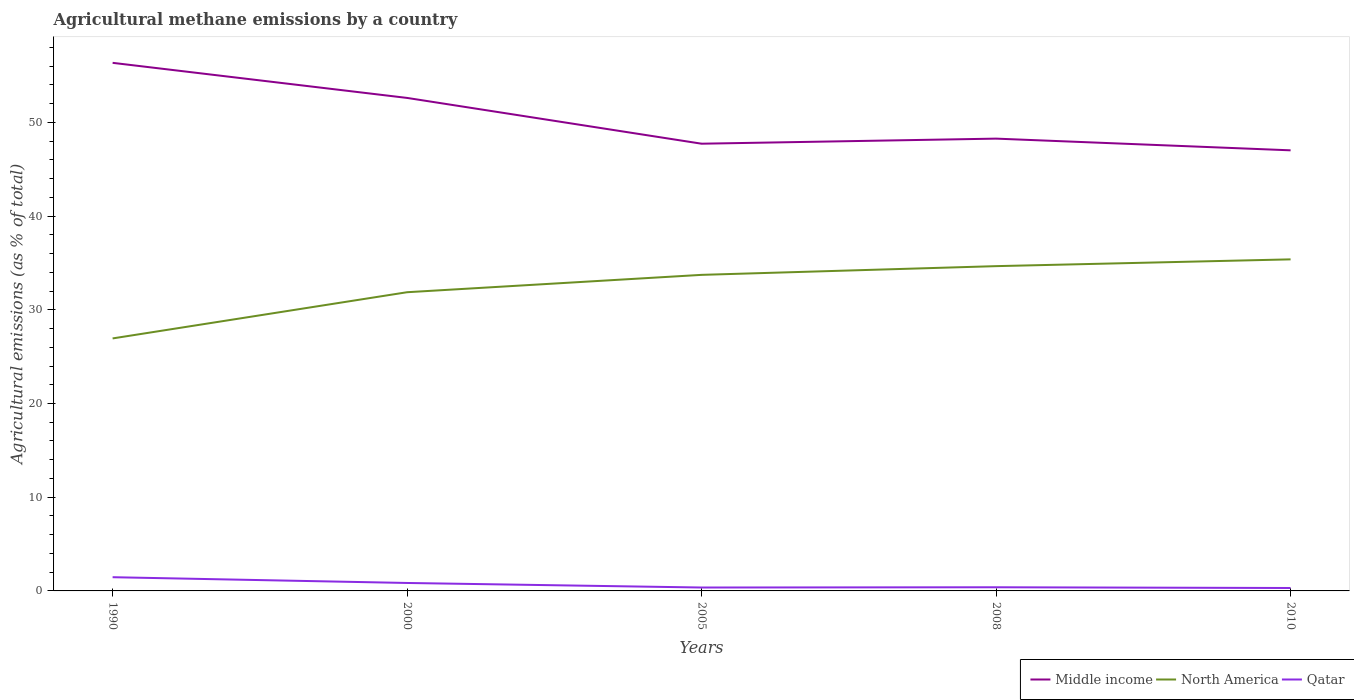How many different coloured lines are there?
Offer a terse response. 3. Does the line corresponding to Qatar intersect with the line corresponding to North America?
Offer a terse response. No. Is the number of lines equal to the number of legend labels?
Offer a terse response. Yes. Across all years, what is the maximum amount of agricultural methane emitted in Middle income?
Ensure brevity in your answer.  47.02. What is the total amount of agricultural methane emitted in Middle income in the graph?
Provide a succinct answer. 5.59. What is the difference between the highest and the second highest amount of agricultural methane emitted in North America?
Give a very brief answer. 8.44. Is the amount of agricultural methane emitted in North America strictly greater than the amount of agricultural methane emitted in Qatar over the years?
Offer a terse response. No. What is the difference between two consecutive major ticks on the Y-axis?
Keep it short and to the point. 10. Are the values on the major ticks of Y-axis written in scientific E-notation?
Your answer should be compact. No. Does the graph contain grids?
Offer a very short reply. No. What is the title of the graph?
Offer a very short reply. Agricultural methane emissions by a country. Does "Fiji" appear as one of the legend labels in the graph?
Give a very brief answer. No. What is the label or title of the Y-axis?
Your answer should be very brief. Agricultural emissions (as % of total). What is the Agricultural emissions (as % of total) in Middle income in 1990?
Your response must be concise. 56.35. What is the Agricultural emissions (as % of total) of North America in 1990?
Offer a very short reply. 26.95. What is the Agricultural emissions (as % of total) in Qatar in 1990?
Offer a terse response. 1.46. What is the Agricultural emissions (as % of total) of Middle income in 2000?
Provide a succinct answer. 52.61. What is the Agricultural emissions (as % of total) in North America in 2000?
Offer a terse response. 31.88. What is the Agricultural emissions (as % of total) in Qatar in 2000?
Provide a short and direct response. 0.85. What is the Agricultural emissions (as % of total) of Middle income in 2005?
Ensure brevity in your answer.  47.72. What is the Agricultural emissions (as % of total) of North America in 2005?
Offer a very short reply. 33.73. What is the Agricultural emissions (as % of total) in Qatar in 2005?
Offer a very short reply. 0.36. What is the Agricultural emissions (as % of total) in Middle income in 2008?
Your response must be concise. 48.27. What is the Agricultural emissions (as % of total) in North America in 2008?
Your answer should be very brief. 34.66. What is the Agricultural emissions (as % of total) in Qatar in 2008?
Ensure brevity in your answer.  0.39. What is the Agricultural emissions (as % of total) in Middle income in 2010?
Your answer should be very brief. 47.02. What is the Agricultural emissions (as % of total) in North America in 2010?
Keep it short and to the point. 35.38. What is the Agricultural emissions (as % of total) of Qatar in 2010?
Provide a succinct answer. 0.31. Across all years, what is the maximum Agricultural emissions (as % of total) in Middle income?
Offer a very short reply. 56.35. Across all years, what is the maximum Agricultural emissions (as % of total) in North America?
Offer a very short reply. 35.38. Across all years, what is the maximum Agricultural emissions (as % of total) of Qatar?
Your response must be concise. 1.46. Across all years, what is the minimum Agricultural emissions (as % of total) in Middle income?
Keep it short and to the point. 47.02. Across all years, what is the minimum Agricultural emissions (as % of total) of North America?
Make the answer very short. 26.95. Across all years, what is the minimum Agricultural emissions (as % of total) in Qatar?
Your answer should be compact. 0.31. What is the total Agricultural emissions (as % of total) of Middle income in the graph?
Give a very brief answer. 251.97. What is the total Agricultural emissions (as % of total) in North America in the graph?
Offer a very short reply. 162.59. What is the total Agricultural emissions (as % of total) in Qatar in the graph?
Give a very brief answer. 3.38. What is the difference between the Agricultural emissions (as % of total) of Middle income in 1990 and that in 2000?
Offer a very short reply. 3.74. What is the difference between the Agricultural emissions (as % of total) of North America in 1990 and that in 2000?
Provide a succinct answer. -4.93. What is the difference between the Agricultural emissions (as % of total) of Qatar in 1990 and that in 2000?
Provide a short and direct response. 0.61. What is the difference between the Agricultural emissions (as % of total) in Middle income in 1990 and that in 2005?
Ensure brevity in your answer.  8.63. What is the difference between the Agricultural emissions (as % of total) in North America in 1990 and that in 2005?
Offer a very short reply. -6.78. What is the difference between the Agricultural emissions (as % of total) in Qatar in 1990 and that in 2005?
Offer a terse response. 1.1. What is the difference between the Agricultural emissions (as % of total) of Middle income in 1990 and that in 2008?
Offer a very short reply. 8.09. What is the difference between the Agricultural emissions (as % of total) in North America in 1990 and that in 2008?
Make the answer very short. -7.71. What is the difference between the Agricultural emissions (as % of total) in Qatar in 1990 and that in 2008?
Keep it short and to the point. 1.07. What is the difference between the Agricultural emissions (as % of total) in Middle income in 1990 and that in 2010?
Offer a terse response. 9.34. What is the difference between the Agricultural emissions (as % of total) in North America in 1990 and that in 2010?
Your response must be concise. -8.44. What is the difference between the Agricultural emissions (as % of total) in Qatar in 1990 and that in 2010?
Offer a very short reply. 1.15. What is the difference between the Agricultural emissions (as % of total) in Middle income in 2000 and that in 2005?
Make the answer very short. 4.89. What is the difference between the Agricultural emissions (as % of total) of North America in 2000 and that in 2005?
Make the answer very short. -1.85. What is the difference between the Agricultural emissions (as % of total) of Qatar in 2000 and that in 2005?
Offer a very short reply. 0.49. What is the difference between the Agricultural emissions (as % of total) of Middle income in 2000 and that in 2008?
Your answer should be very brief. 4.34. What is the difference between the Agricultural emissions (as % of total) in North America in 2000 and that in 2008?
Make the answer very short. -2.78. What is the difference between the Agricultural emissions (as % of total) in Qatar in 2000 and that in 2008?
Make the answer very short. 0.46. What is the difference between the Agricultural emissions (as % of total) in Middle income in 2000 and that in 2010?
Provide a succinct answer. 5.59. What is the difference between the Agricultural emissions (as % of total) of North America in 2000 and that in 2010?
Provide a short and direct response. -3.51. What is the difference between the Agricultural emissions (as % of total) in Qatar in 2000 and that in 2010?
Your answer should be very brief. 0.54. What is the difference between the Agricultural emissions (as % of total) of Middle income in 2005 and that in 2008?
Offer a terse response. -0.54. What is the difference between the Agricultural emissions (as % of total) in North America in 2005 and that in 2008?
Ensure brevity in your answer.  -0.93. What is the difference between the Agricultural emissions (as % of total) of Qatar in 2005 and that in 2008?
Keep it short and to the point. -0.03. What is the difference between the Agricultural emissions (as % of total) of Middle income in 2005 and that in 2010?
Offer a very short reply. 0.71. What is the difference between the Agricultural emissions (as % of total) in North America in 2005 and that in 2010?
Give a very brief answer. -1.65. What is the difference between the Agricultural emissions (as % of total) in Qatar in 2005 and that in 2010?
Your response must be concise. 0.05. What is the difference between the Agricultural emissions (as % of total) in Middle income in 2008 and that in 2010?
Offer a terse response. 1.25. What is the difference between the Agricultural emissions (as % of total) in North America in 2008 and that in 2010?
Your answer should be very brief. -0.72. What is the difference between the Agricultural emissions (as % of total) of Qatar in 2008 and that in 2010?
Give a very brief answer. 0.08. What is the difference between the Agricultural emissions (as % of total) in Middle income in 1990 and the Agricultural emissions (as % of total) in North America in 2000?
Your response must be concise. 24.48. What is the difference between the Agricultural emissions (as % of total) of Middle income in 1990 and the Agricultural emissions (as % of total) of Qatar in 2000?
Your answer should be compact. 55.51. What is the difference between the Agricultural emissions (as % of total) in North America in 1990 and the Agricultural emissions (as % of total) in Qatar in 2000?
Keep it short and to the point. 26.1. What is the difference between the Agricultural emissions (as % of total) of Middle income in 1990 and the Agricultural emissions (as % of total) of North America in 2005?
Keep it short and to the point. 22.63. What is the difference between the Agricultural emissions (as % of total) of Middle income in 1990 and the Agricultural emissions (as % of total) of Qatar in 2005?
Your answer should be compact. 55.99. What is the difference between the Agricultural emissions (as % of total) of North America in 1990 and the Agricultural emissions (as % of total) of Qatar in 2005?
Keep it short and to the point. 26.58. What is the difference between the Agricultural emissions (as % of total) of Middle income in 1990 and the Agricultural emissions (as % of total) of North America in 2008?
Offer a terse response. 21.7. What is the difference between the Agricultural emissions (as % of total) in Middle income in 1990 and the Agricultural emissions (as % of total) in Qatar in 2008?
Offer a very short reply. 55.96. What is the difference between the Agricultural emissions (as % of total) in North America in 1990 and the Agricultural emissions (as % of total) in Qatar in 2008?
Offer a very short reply. 26.56. What is the difference between the Agricultural emissions (as % of total) in Middle income in 1990 and the Agricultural emissions (as % of total) in North America in 2010?
Offer a terse response. 20.97. What is the difference between the Agricultural emissions (as % of total) in Middle income in 1990 and the Agricultural emissions (as % of total) in Qatar in 2010?
Provide a succinct answer. 56.04. What is the difference between the Agricultural emissions (as % of total) of North America in 1990 and the Agricultural emissions (as % of total) of Qatar in 2010?
Offer a very short reply. 26.63. What is the difference between the Agricultural emissions (as % of total) in Middle income in 2000 and the Agricultural emissions (as % of total) in North America in 2005?
Offer a very short reply. 18.88. What is the difference between the Agricultural emissions (as % of total) in Middle income in 2000 and the Agricultural emissions (as % of total) in Qatar in 2005?
Offer a very short reply. 52.25. What is the difference between the Agricultural emissions (as % of total) in North America in 2000 and the Agricultural emissions (as % of total) in Qatar in 2005?
Ensure brevity in your answer.  31.51. What is the difference between the Agricultural emissions (as % of total) in Middle income in 2000 and the Agricultural emissions (as % of total) in North America in 2008?
Give a very brief answer. 17.95. What is the difference between the Agricultural emissions (as % of total) of Middle income in 2000 and the Agricultural emissions (as % of total) of Qatar in 2008?
Your answer should be compact. 52.22. What is the difference between the Agricultural emissions (as % of total) in North America in 2000 and the Agricultural emissions (as % of total) in Qatar in 2008?
Make the answer very short. 31.49. What is the difference between the Agricultural emissions (as % of total) in Middle income in 2000 and the Agricultural emissions (as % of total) in North America in 2010?
Provide a succinct answer. 17.23. What is the difference between the Agricultural emissions (as % of total) in Middle income in 2000 and the Agricultural emissions (as % of total) in Qatar in 2010?
Your answer should be compact. 52.3. What is the difference between the Agricultural emissions (as % of total) in North America in 2000 and the Agricultural emissions (as % of total) in Qatar in 2010?
Provide a succinct answer. 31.56. What is the difference between the Agricultural emissions (as % of total) of Middle income in 2005 and the Agricultural emissions (as % of total) of North America in 2008?
Keep it short and to the point. 13.07. What is the difference between the Agricultural emissions (as % of total) of Middle income in 2005 and the Agricultural emissions (as % of total) of Qatar in 2008?
Offer a terse response. 47.33. What is the difference between the Agricultural emissions (as % of total) of North America in 2005 and the Agricultural emissions (as % of total) of Qatar in 2008?
Ensure brevity in your answer.  33.34. What is the difference between the Agricultural emissions (as % of total) in Middle income in 2005 and the Agricultural emissions (as % of total) in North America in 2010?
Your answer should be compact. 12.34. What is the difference between the Agricultural emissions (as % of total) of Middle income in 2005 and the Agricultural emissions (as % of total) of Qatar in 2010?
Keep it short and to the point. 47.41. What is the difference between the Agricultural emissions (as % of total) in North America in 2005 and the Agricultural emissions (as % of total) in Qatar in 2010?
Your answer should be very brief. 33.42. What is the difference between the Agricultural emissions (as % of total) in Middle income in 2008 and the Agricultural emissions (as % of total) in North America in 2010?
Your response must be concise. 12.88. What is the difference between the Agricultural emissions (as % of total) of Middle income in 2008 and the Agricultural emissions (as % of total) of Qatar in 2010?
Give a very brief answer. 47.95. What is the difference between the Agricultural emissions (as % of total) of North America in 2008 and the Agricultural emissions (as % of total) of Qatar in 2010?
Keep it short and to the point. 34.35. What is the average Agricultural emissions (as % of total) in Middle income per year?
Keep it short and to the point. 50.39. What is the average Agricultural emissions (as % of total) of North America per year?
Ensure brevity in your answer.  32.52. What is the average Agricultural emissions (as % of total) in Qatar per year?
Your answer should be very brief. 0.68. In the year 1990, what is the difference between the Agricultural emissions (as % of total) in Middle income and Agricultural emissions (as % of total) in North America?
Your answer should be very brief. 29.41. In the year 1990, what is the difference between the Agricultural emissions (as % of total) in Middle income and Agricultural emissions (as % of total) in Qatar?
Provide a succinct answer. 54.89. In the year 1990, what is the difference between the Agricultural emissions (as % of total) of North America and Agricultural emissions (as % of total) of Qatar?
Make the answer very short. 25.48. In the year 2000, what is the difference between the Agricultural emissions (as % of total) of Middle income and Agricultural emissions (as % of total) of North America?
Your answer should be compact. 20.73. In the year 2000, what is the difference between the Agricultural emissions (as % of total) of Middle income and Agricultural emissions (as % of total) of Qatar?
Give a very brief answer. 51.76. In the year 2000, what is the difference between the Agricultural emissions (as % of total) in North America and Agricultural emissions (as % of total) in Qatar?
Provide a short and direct response. 31.03. In the year 2005, what is the difference between the Agricultural emissions (as % of total) of Middle income and Agricultural emissions (as % of total) of North America?
Offer a very short reply. 14. In the year 2005, what is the difference between the Agricultural emissions (as % of total) in Middle income and Agricultural emissions (as % of total) in Qatar?
Provide a succinct answer. 47.36. In the year 2005, what is the difference between the Agricultural emissions (as % of total) in North America and Agricultural emissions (as % of total) in Qatar?
Your answer should be very brief. 33.37. In the year 2008, what is the difference between the Agricultural emissions (as % of total) of Middle income and Agricultural emissions (as % of total) of North America?
Ensure brevity in your answer.  13.61. In the year 2008, what is the difference between the Agricultural emissions (as % of total) of Middle income and Agricultural emissions (as % of total) of Qatar?
Offer a terse response. 47.88. In the year 2008, what is the difference between the Agricultural emissions (as % of total) in North America and Agricultural emissions (as % of total) in Qatar?
Offer a terse response. 34.27. In the year 2010, what is the difference between the Agricultural emissions (as % of total) of Middle income and Agricultural emissions (as % of total) of North America?
Your response must be concise. 11.64. In the year 2010, what is the difference between the Agricultural emissions (as % of total) of Middle income and Agricultural emissions (as % of total) of Qatar?
Give a very brief answer. 46.71. In the year 2010, what is the difference between the Agricultural emissions (as % of total) of North America and Agricultural emissions (as % of total) of Qatar?
Provide a succinct answer. 35.07. What is the ratio of the Agricultural emissions (as % of total) in Middle income in 1990 to that in 2000?
Provide a short and direct response. 1.07. What is the ratio of the Agricultural emissions (as % of total) in North America in 1990 to that in 2000?
Provide a succinct answer. 0.85. What is the ratio of the Agricultural emissions (as % of total) in Qatar in 1990 to that in 2000?
Provide a succinct answer. 1.72. What is the ratio of the Agricultural emissions (as % of total) of Middle income in 1990 to that in 2005?
Your response must be concise. 1.18. What is the ratio of the Agricultural emissions (as % of total) of North America in 1990 to that in 2005?
Your answer should be very brief. 0.8. What is the ratio of the Agricultural emissions (as % of total) in Qatar in 1990 to that in 2005?
Provide a short and direct response. 4.04. What is the ratio of the Agricultural emissions (as % of total) in Middle income in 1990 to that in 2008?
Offer a terse response. 1.17. What is the ratio of the Agricultural emissions (as % of total) in North America in 1990 to that in 2008?
Keep it short and to the point. 0.78. What is the ratio of the Agricultural emissions (as % of total) of Qatar in 1990 to that in 2008?
Your response must be concise. 3.76. What is the ratio of the Agricultural emissions (as % of total) in Middle income in 1990 to that in 2010?
Provide a succinct answer. 1.2. What is the ratio of the Agricultural emissions (as % of total) in North America in 1990 to that in 2010?
Offer a very short reply. 0.76. What is the ratio of the Agricultural emissions (as % of total) of Qatar in 1990 to that in 2010?
Give a very brief answer. 4.69. What is the ratio of the Agricultural emissions (as % of total) of Middle income in 2000 to that in 2005?
Your response must be concise. 1.1. What is the ratio of the Agricultural emissions (as % of total) in North America in 2000 to that in 2005?
Your answer should be compact. 0.95. What is the ratio of the Agricultural emissions (as % of total) in Qatar in 2000 to that in 2005?
Make the answer very short. 2.34. What is the ratio of the Agricultural emissions (as % of total) in Middle income in 2000 to that in 2008?
Offer a terse response. 1.09. What is the ratio of the Agricultural emissions (as % of total) of North America in 2000 to that in 2008?
Your answer should be compact. 0.92. What is the ratio of the Agricultural emissions (as % of total) in Qatar in 2000 to that in 2008?
Provide a succinct answer. 2.18. What is the ratio of the Agricultural emissions (as % of total) in Middle income in 2000 to that in 2010?
Keep it short and to the point. 1.12. What is the ratio of the Agricultural emissions (as % of total) of North America in 2000 to that in 2010?
Your response must be concise. 0.9. What is the ratio of the Agricultural emissions (as % of total) in Qatar in 2000 to that in 2010?
Offer a very short reply. 2.72. What is the ratio of the Agricultural emissions (as % of total) of North America in 2005 to that in 2008?
Offer a terse response. 0.97. What is the ratio of the Agricultural emissions (as % of total) of Qatar in 2005 to that in 2008?
Keep it short and to the point. 0.93. What is the ratio of the Agricultural emissions (as % of total) in North America in 2005 to that in 2010?
Offer a terse response. 0.95. What is the ratio of the Agricultural emissions (as % of total) in Qatar in 2005 to that in 2010?
Ensure brevity in your answer.  1.16. What is the ratio of the Agricultural emissions (as % of total) of Middle income in 2008 to that in 2010?
Your answer should be very brief. 1.03. What is the ratio of the Agricultural emissions (as % of total) of North America in 2008 to that in 2010?
Provide a short and direct response. 0.98. What is the ratio of the Agricultural emissions (as % of total) of Qatar in 2008 to that in 2010?
Offer a very short reply. 1.25. What is the difference between the highest and the second highest Agricultural emissions (as % of total) of Middle income?
Make the answer very short. 3.74. What is the difference between the highest and the second highest Agricultural emissions (as % of total) of North America?
Keep it short and to the point. 0.72. What is the difference between the highest and the second highest Agricultural emissions (as % of total) of Qatar?
Your response must be concise. 0.61. What is the difference between the highest and the lowest Agricultural emissions (as % of total) of Middle income?
Your response must be concise. 9.34. What is the difference between the highest and the lowest Agricultural emissions (as % of total) of North America?
Keep it short and to the point. 8.44. What is the difference between the highest and the lowest Agricultural emissions (as % of total) of Qatar?
Your response must be concise. 1.15. 